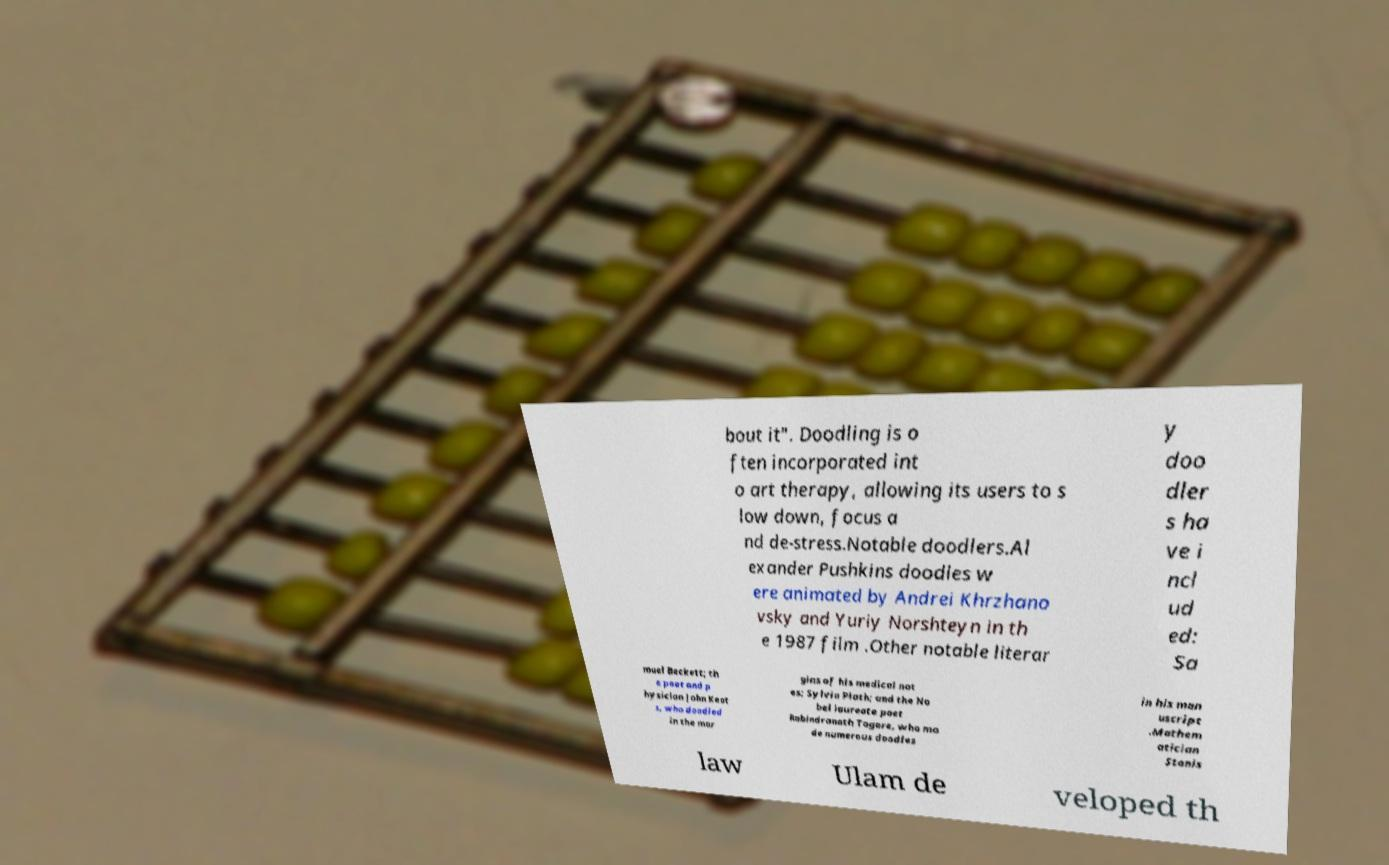I need the written content from this picture converted into text. Can you do that? bout it". Doodling is o ften incorporated int o art therapy, allowing its users to s low down, focus a nd de-stress.Notable doodlers.Al exander Pushkins doodles w ere animated by Andrei Khrzhano vsky and Yuriy Norshteyn in th e 1987 film .Other notable literar y doo dler s ha ve i ncl ud ed: Sa muel Beckett; th e poet and p hysician John Keat s, who doodled in the mar gins of his medical not es; Sylvia Plath; and the No bel laureate poet Rabindranath Tagore, who ma de numerous doodles in his man uscript .Mathem atician Stanis law Ulam de veloped th 